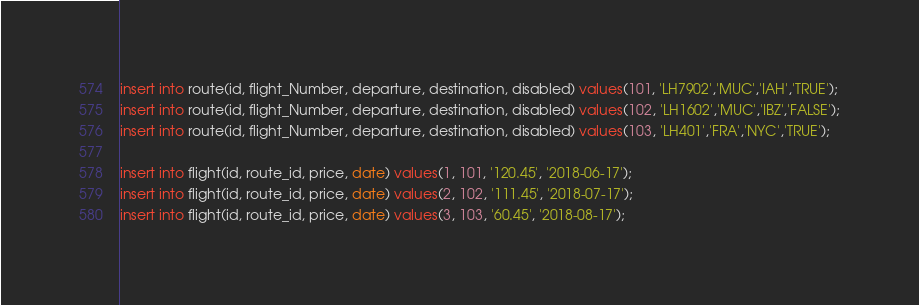<code> <loc_0><loc_0><loc_500><loc_500><_SQL_>
insert into route(id, flight_Number, departure, destination, disabled) values(101, 'LH7902','MUC','IAH','TRUE');
insert into route(id, flight_Number, departure, destination, disabled) values(102, 'LH1602','MUC','IBZ','FALSE');
insert into route(id, flight_Number, departure, destination, disabled) values(103, 'LH401','FRA','NYC','TRUE');

insert into flight(id, route_id, price, date) values(1, 101, '120.45', '2018-06-17');
insert into flight(id, route_id, price, date) values(2, 102, '111.45', '2018-07-17');
insert into flight(id, route_id, price, date) values(3, 103, '60.45', '2018-08-17');</code> 